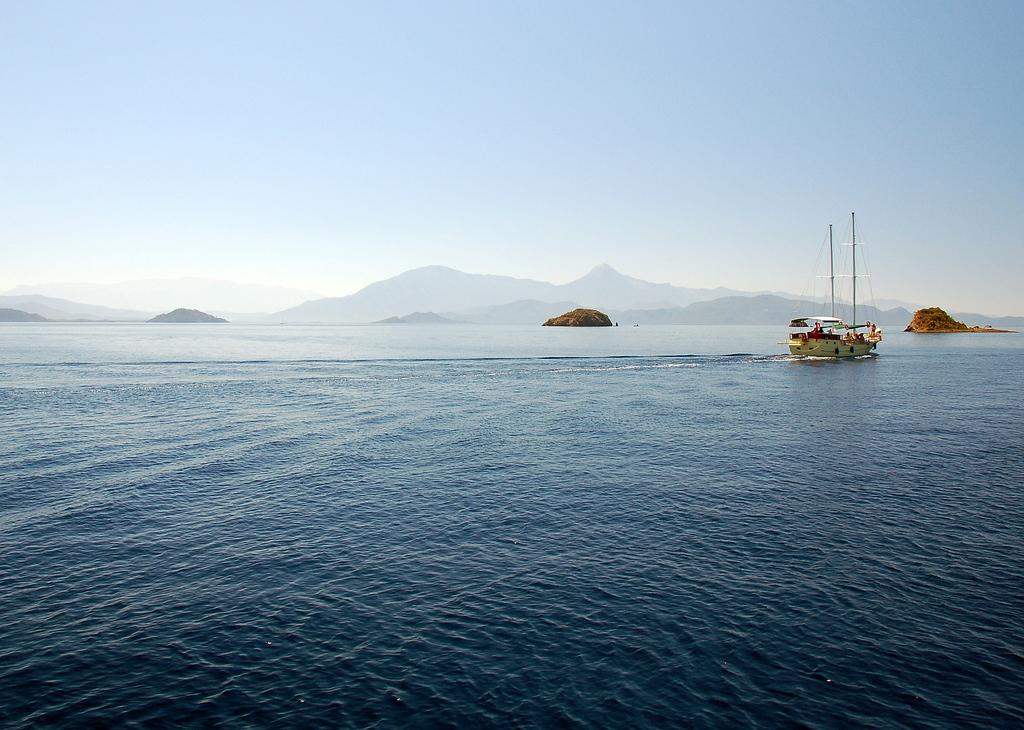What is the main subject of the image? The main subject of the image is a boat. What is the boat doing in the image? The boat is moving on the water in the image. What can be seen in the background of the image? In the background of the image, there are hills and tiny islands visible. What else is visible in the image? The sky is visible in the image. How many women are sitting on the boat in the image? There are no women present in the image; it only features a boat moving on the water. What type of arch can be seen supporting the boat in the image? There is no arch visible in the image; the boat is moving on the water without any visible support. 